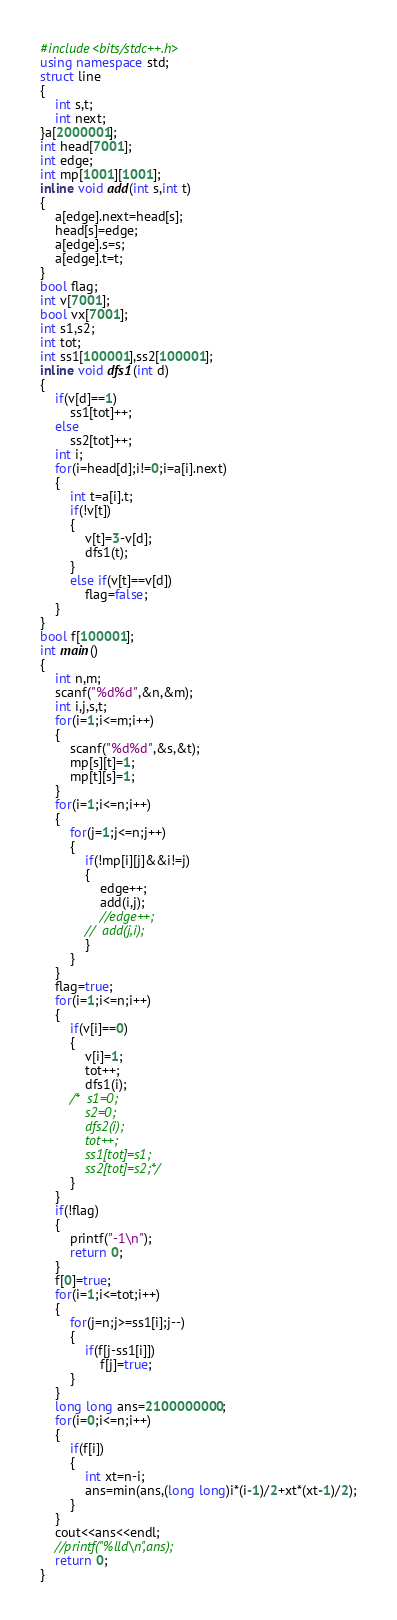Convert code to text. <code><loc_0><loc_0><loc_500><loc_500><_C++_>#include<bits/stdc++.h>
using namespace std;
struct line
{
	int s,t;
	int next;
}a[2000001];
int head[7001];
int edge;
int mp[1001][1001];
inline void add(int s,int t)
{
	a[edge].next=head[s];
	head[s]=edge;
	a[edge].s=s;
	a[edge].t=t;
}
bool flag;
int v[7001];
bool vx[7001];
int s1,s2;
int tot;
int ss1[100001],ss2[100001];
inline void dfs1(int d)
{
	if(v[d]==1)
		ss1[tot]++;
	else
		ss2[tot]++;
	int i;
	for(i=head[d];i!=0;i=a[i].next)
	{
		int t=a[i].t;
		if(!v[t])
		{
			v[t]=3-v[d];
			dfs1(t);
		}
		else if(v[t]==v[d])
			flag=false;
	}
}
bool f[100001];
int main()
{
	int n,m;
	scanf("%d%d",&n,&m);
	int i,j,s,t;
	for(i=1;i<=m;i++)
	{
		scanf("%d%d",&s,&t);
		mp[s][t]=1;
		mp[t][s]=1;
	}
	for(i=1;i<=n;i++)
	{
		for(j=1;j<=n;j++)
		{
			if(!mp[i][j]&&i!=j)
			{
				edge++;
				add(i,j);
				//edge++;
			//	add(j,i);
			}
		}
	}
	flag=true;
	for(i=1;i<=n;i++) 
	{
		if(v[i]==0)
		{
			v[i]=1;
			tot++;
			dfs1(i);
		/*	s1=0;
			s2=0;
			dfs2(i);
			tot++;
			ss1[tot]=s1;
			ss2[tot]=s2;*/
		}
	}
	if(!flag)
	{
		printf("-1\n");
		return 0;
	}
	f[0]=true;
	for(i=1;i<=tot;i++)
	{
		for(j=n;j>=ss1[i];j--)
		{
			if(f[j-ss1[i]])
				f[j]=true;
		}
	}
	long long ans=2100000000;
	for(i=0;i<=n;i++)
	{
		if(f[i])
		{
			int xt=n-i;
			ans=min(ans,(long long)i*(i-1)/2+xt*(xt-1)/2);
		}
	}
	cout<<ans<<endl;
	//printf("%lld\n",ans);
	return 0;
}</code> 